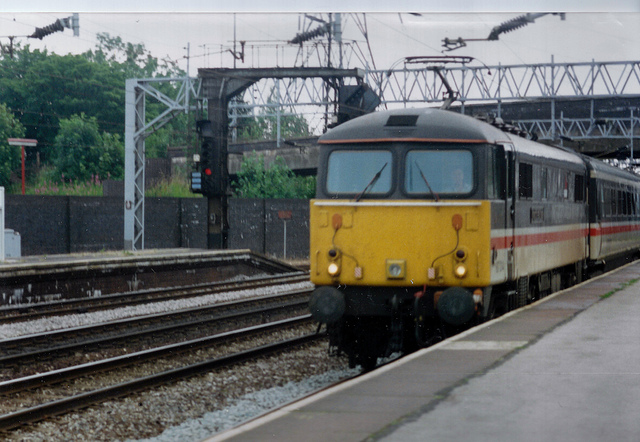Please transcribe the text information in this image. U 